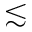<formula> <loc_0><loc_0><loc_500><loc_500>\lesssim</formula> 